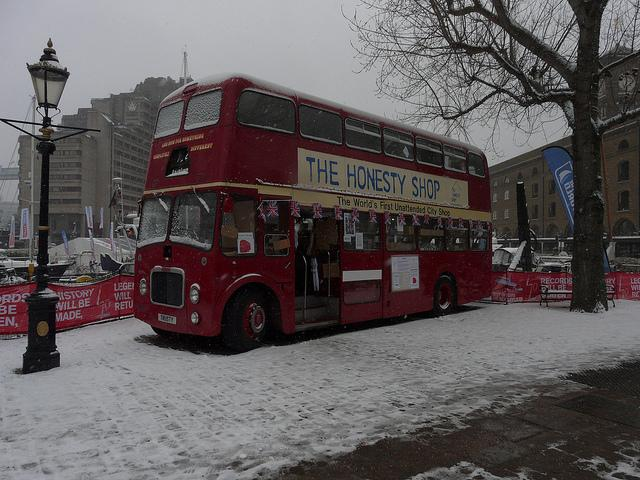Which side of the bus can people enter through? Please explain your reasoning. driver side. The bus can accept people for entry at the driver side. 